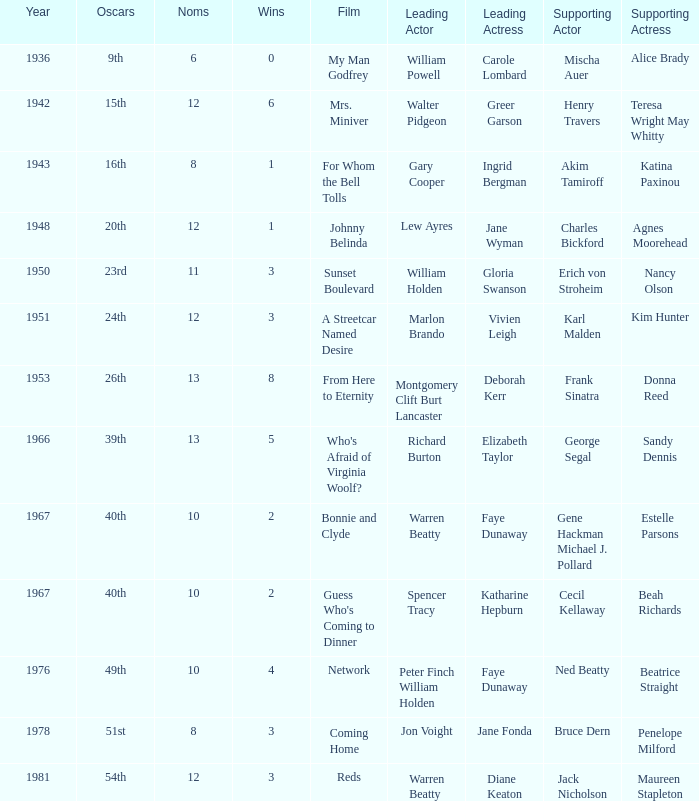Who was the leading actor in the film with a supporting actor named Cecil Kellaway? Spencer Tracy. 